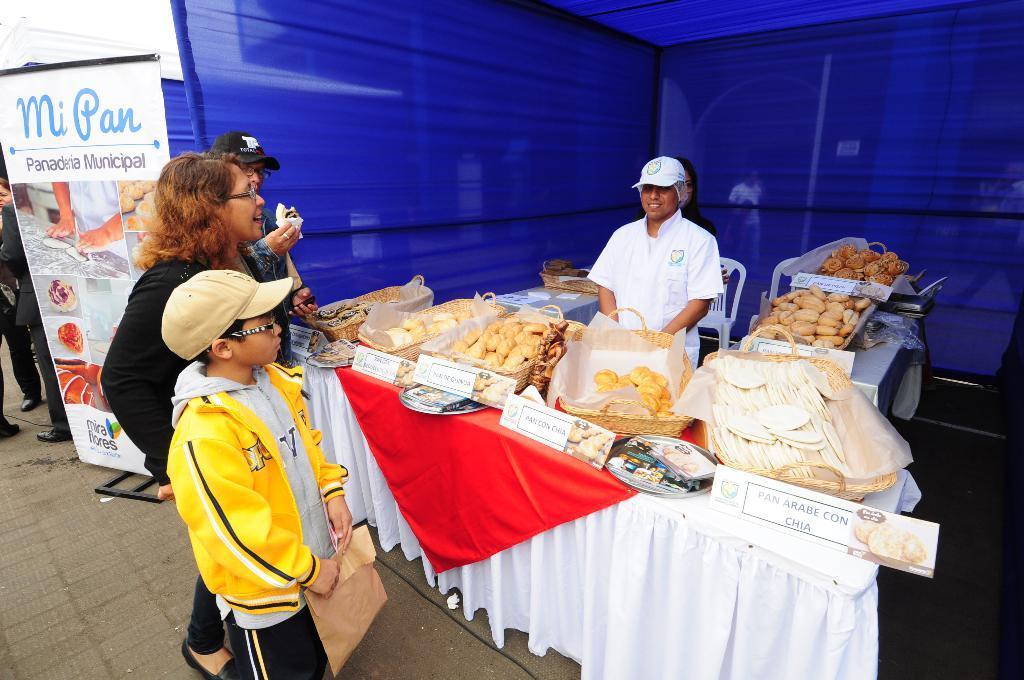In one or two sentences, can you explain what this image depicts? In this image I can see few persons are standing, a table and on the table I can see few boards and few baskets with food items in them. I can see a person standing, a chair, a blue colored tent and a banner. 